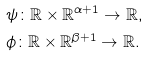Convert formula to latex. <formula><loc_0><loc_0><loc_500><loc_500>& \psi \colon { \mathbb { R } } \times { \mathbb { R } } ^ { \alpha + 1 } \to { \mathbb { R } } , \\ & \phi \colon { \mathbb { R } } \times { \mathbb { R } } ^ { \beta + 1 } \to { \mathbb { R } } .</formula> 